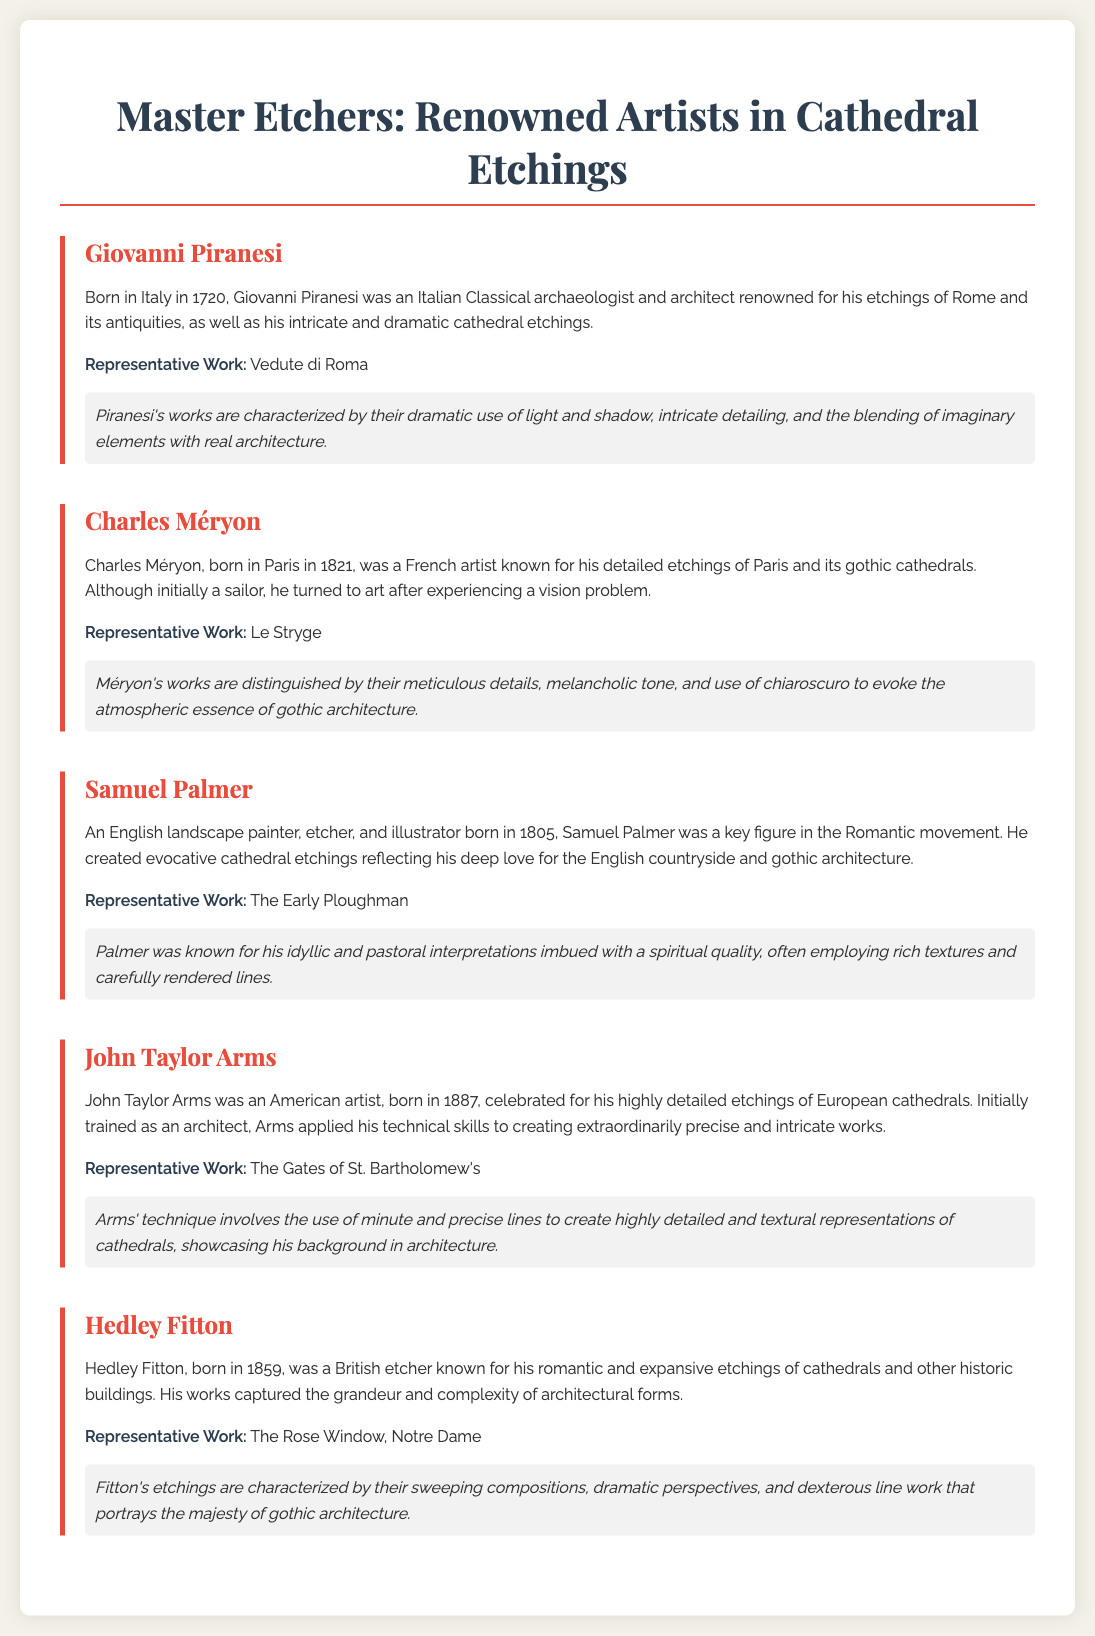What is the title of the poster? The title of the poster prominently displayed at the top is "Master Etchers: Renowned Artists in Cathedral Etchings."
Answer: Master Etchers: Renowned Artists in Cathedral Etchings Who is the artist known for "Vedute di Roma"? Giovanni Piranesi is the artist associated with "Vedute di Roma," which is mentioned as his representative work.
Answer: Giovanni Piranesi When was Charles Méryon born? The document states that Charles Méryon was born in 1821.
Answer: 1821 Which artist was initially trained as an architect? The document specifies that John Taylor Arms was initially trained as an architect before becoming an artist.
Answer: John Taylor Arms What is the signature technique of Hedley Fitton? The signature technique of Hedley Fitton involves sweeping compositions, dramatic perspectives, and dexterous line work.
Answer: Sweeping compositions, dramatic perspectives, and dexterous line work Which artist is associated with the etching titled "The Early Ploughman"? Samuel Palmer is noted for the etching titled "The Early Ploughman" in the document.
Answer: Samuel Palmer What significant theme is highlighted in Charles Méryon's works? The document highlights that Méryon's works carry a melancholic tone and emphasize atmospheric essence.
Answer: Melancholic tone and atmospheric essence How many artists are featured in the poster? The poster includes five renowned artists in the field of cathedral etchings.
Answer: Five 